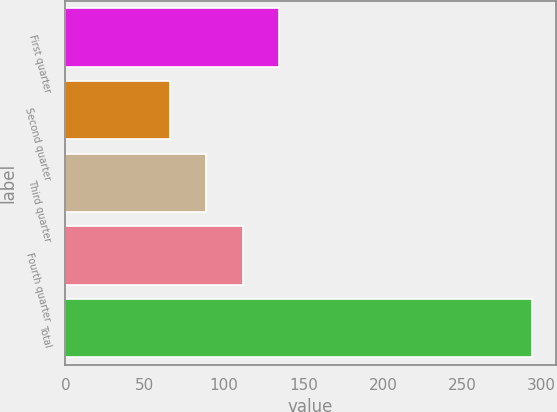Convert chart to OTSL. <chart><loc_0><loc_0><loc_500><loc_500><bar_chart><fcel>First quarter<fcel>Second quarter<fcel>Third quarter<fcel>Fourth quarter<fcel>Total<nl><fcel>134.4<fcel>66<fcel>88.8<fcel>111.6<fcel>294<nl></chart> 